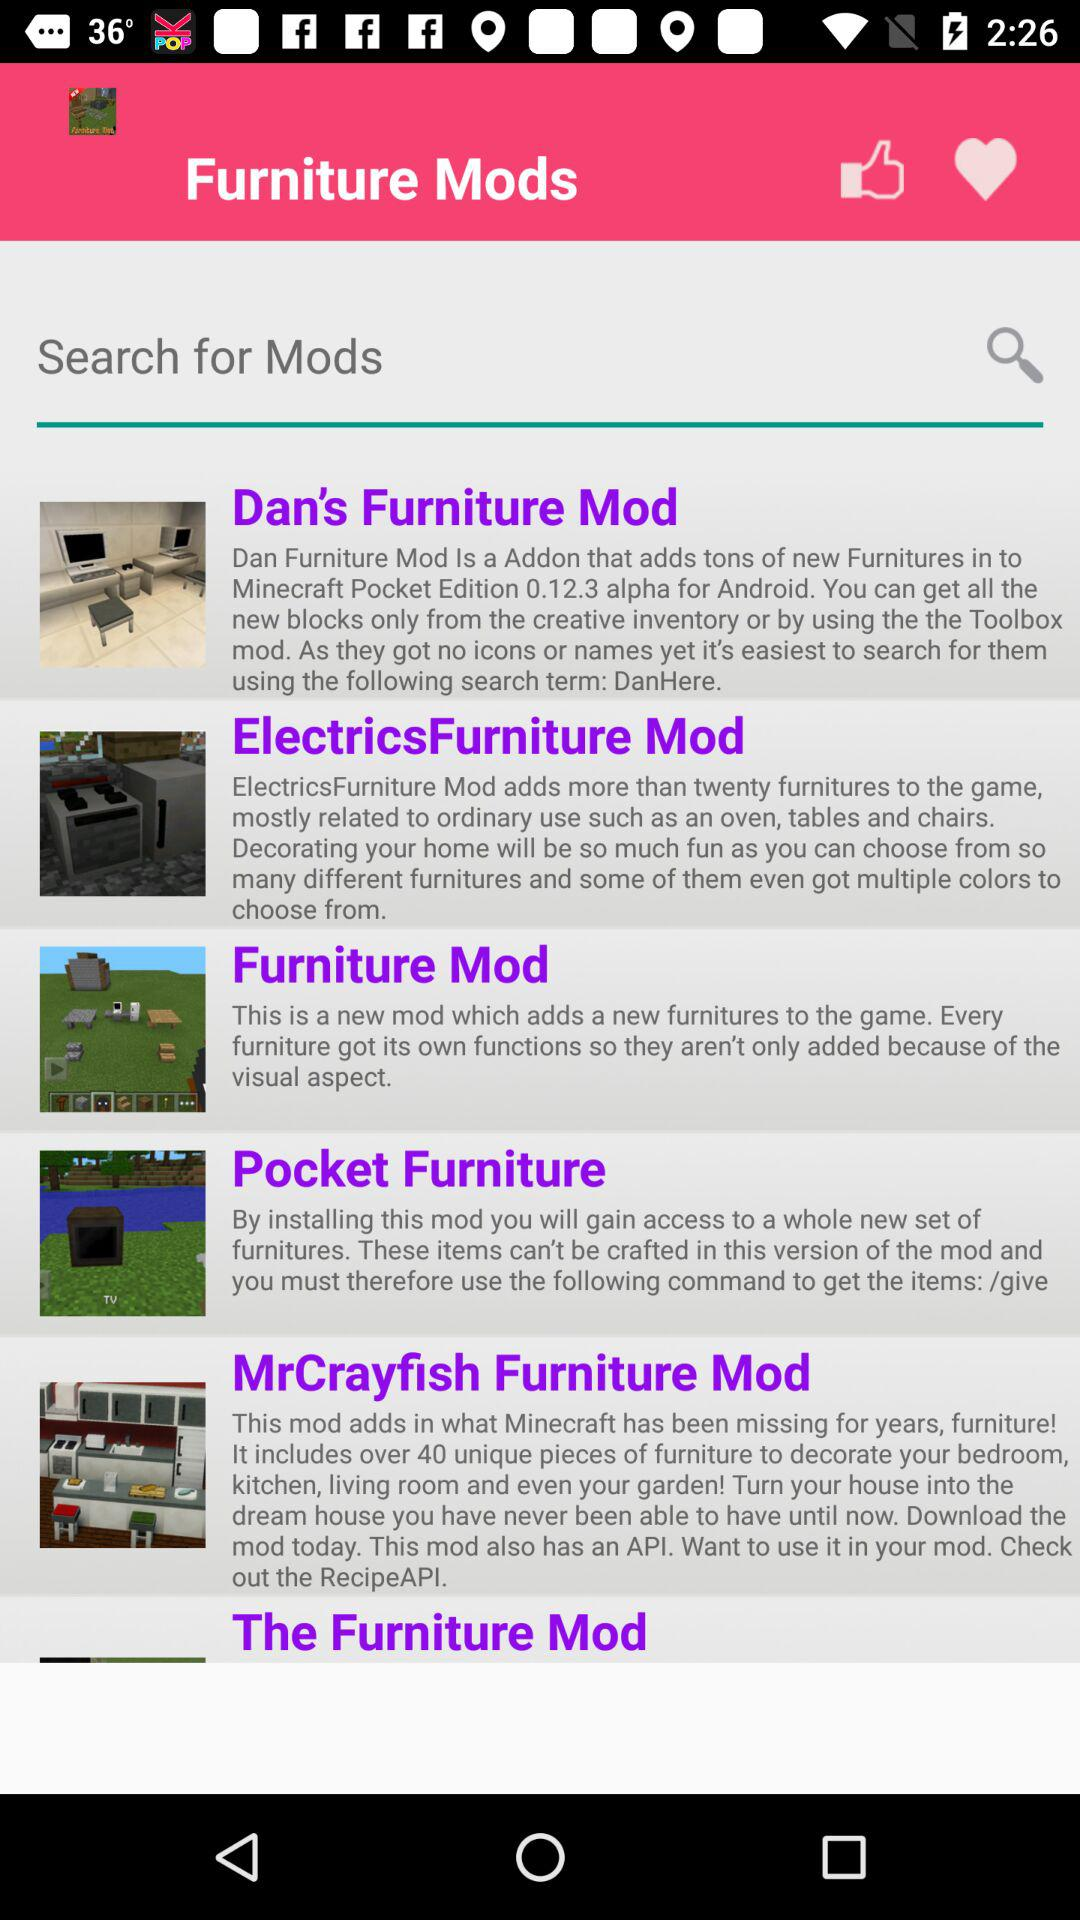What furniture mod has 40 unique pieces of furniture to decorate your bedroom? The furniture mod is "MrCrayfish Furniture Mod". 